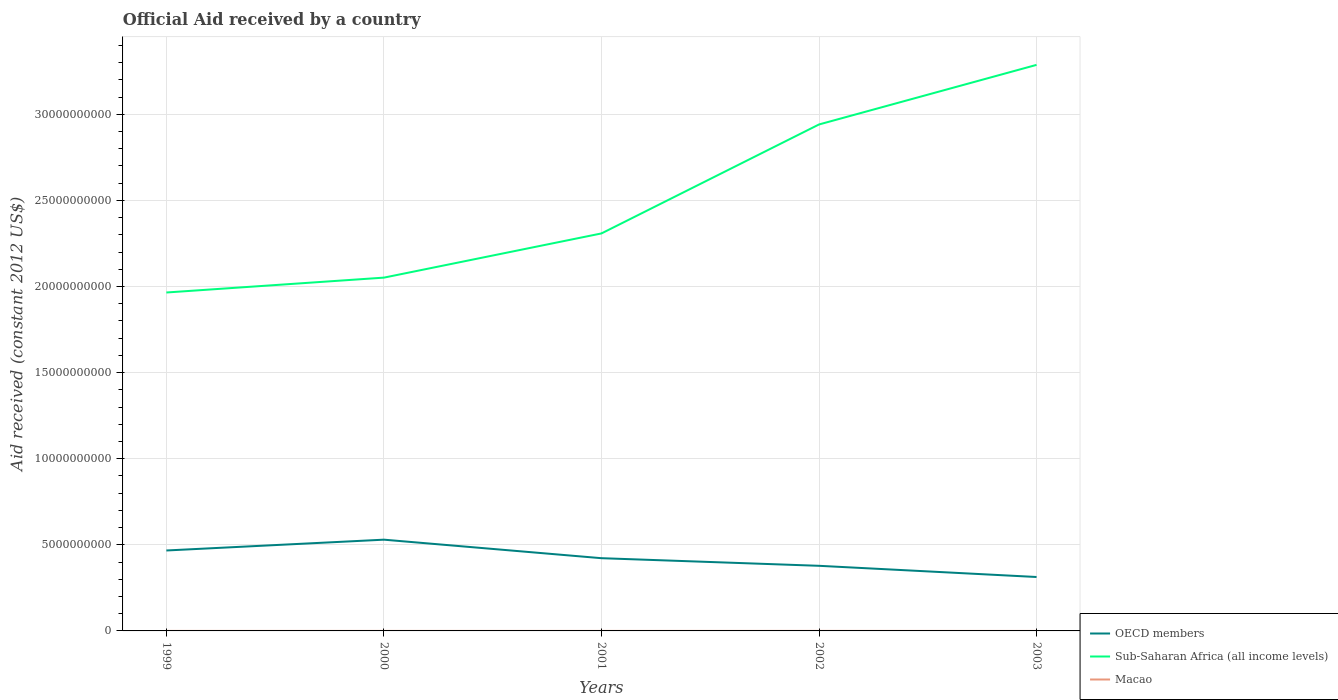How many different coloured lines are there?
Ensure brevity in your answer.  3. Does the line corresponding to Macao intersect with the line corresponding to Sub-Saharan Africa (all income levels)?
Give a very brief answer. No. Is the number of lines equal to the number of legend labels?
Keep it short and to the point. Yes. Across all years, what is the maximum net official aid received in Sub-Saharan Africa (all income levels)?
Your answer should be compact. 1.96e+1. What is the total net official aid received in Macao in the graph?
Make the answer very short. -7.20e+05. What is the difference between the highest and the second highest net official aid received in Macao?
Your answer should be compact. 1.40e+06. Is the net official aid received in OECD members strictly greater than the net official aid received in Sub-Saharan Africa (all income levels) over the years?
Ensure brevity in your answer.  Yes. How many years are there in the graph?
Offer a terse response. 5. What is the difference between two consecutive major ticks on the Y-axis?
Offer a terse response. 5.00e+09. Are the values on the major ticks of Y-axis written in scientific E-notation?
Provide a succinct answer. No. Does the graph contain any zero values?
Keep it short and to the point. No. Where does the legend appear in the graph?
Provide a succinct answer. Bottom right. How many legend labels are there?
Provide a short and direct response. 3. What is the title of the graph?
Your response must be concise. Official Aid received by a country. What is the label or title of the X-axis?
Offer a terse response. Years. What is the label or title of the Y-axis?
Provide a succinct answer. Aid received (constant 2012 US$). What is the Aid received (constant 2012 US$) of OECD members in 1999?
Keep it short and to the point. 4.67e+09. What is the Aid received (constant 2012 US$) of Sub-Saharan Africa (all income levels) in 1999?
Your answer should be very brief. 1.96e+1. What is the Aid received (constant 2012 US$) in Macao in 1999?
Offer a very short reply. 4.20e+05. What is the Aid received (constant 2012 US$) in OECD members in 2000?
Your response must be concise. 5.30e+09. What is the Aid received (constant 2012 US$) of Sub-Saharan Africa (all income levels) in 2000?
Keep it short and to the point. 2.05e+1. What is the Aid received (constant 2012 US$) of Macao in 2000?
Make the answer very short. 1.08e+06. What is the Aid received (constant 2012 US$) of OECD members in 2001?
Offer a very short reply. 4.22e+09. What is the Aid received (constant 2012 US$) of Sub-Saharan Africa (all income levels) in 2001?
Give a very brief answer. 2.31e+1. What is the Aid received (constant 2012 US$) in Macao in 2001?
Your answer should be very brief. 8.60e+05. What is the Aid received (constant 2012 US$) of OECD members in 2002?
Keep it short and to the point. 3.78e+09. What is the Aid received (constant 2012 US$) in Sub-Saharan Africa (all income levels) in 2002?
Your answer should be very brief. 2.94e+1. What is the Aid received (constant 2012 US$) in Macao in 2002?
Your response must be concise. 1.58e+06. What is the Aid received (constant 2012 US$) of OECD members in 2003?
Your answer should be compact. 3.13e+09. What is the Aid received (constant 2012 US$) of Sub-Saharan Africa (all income levels) in 2003?
Your answer should be compact. 3.29e+1. What is the Aid received (constant 2012 US$) in Macao in 2003?
Offer a terse response. 1.80e+05. Across all years, what is the maximum Aid received (constant 2012 US$) of OECD members?
Keep it short and to the point. 5.30e+09. Across all years, what is the maximum Aid received (constant 2012 US$) in Sub-Saharan Africa (all income levels)?
Provide a succinct answer. 3.29e+1. Across all years, what is the maximum Aid received (constant 2012 US$) in Macao?
Keep it short and to the point. 1.58e+06. Across all years, what is the minimum Aid received (constant 2012 US$) of OECD members?
Provide a succinct answer. 3.13e+09. Across all years, what is the minimum Aid received (constant 2012 US$) of Sub-Saharan Africa (all income levels)?
Give a very brief answer. 1.96e+1. What is the total Aid received (constant 2012 US$) of OECD members in the graph?
Provide a succinct answer. 2.11e+1. What is the total Aid received (constant 2012 US$) in Sub-Saharan Africa (all income levels) in the graph?
Ensure brevity in your answer.  1.26e+11. What is the total Aid received (constant 2012 US$) in Macao in the graph?
Provide a succinct answer. 4.12e+06. What is the difference between the Aid received (constant 2012 US$) of OECD members in 1999 and that in 2000?
Ensure brevity in your answer.  -6.28e+08. What is the difference between the Aid received (constant 2012 US$) of Sub-Saharan Africa (all income levels) in 1999 and that in 2000?
Give a very brief answer. -8.63e+08. What is the difference between the Aid received (constant 2012 US$) of Macao in 1999 and that in 2000?
Your answer should be compact. -6.60e+05. What is the difference between the Aid received (constant 2012 US$) of OECD members in 1999 and that in 2001?
Your answer should be compact. 4.47e+08. What is the difference between the Aid received (constant 2012 US$) of Sub-Saharan Africa (all income levels) in 1999 and that in 2001?
Provide a short and direct response. -3.43e+09. What is the difference between the Aid received (constant 2012 US$) in Macao in 1999 and that in 2001?
Offer a very short reply. -4.40e+05. What is the difference between the Aid received (constant 2012 US$) in OECD members in 1999 and that in 2002?
Offer a terse response. 8.89e+08. What is the difference between the Aid received (constant 2012 US$) of Sub-Saharan Africa (all income levels) in 1999 and that in 2002?
Offer a very short reply. -9.76e+09. What is the difference between the Aid received (constant 2012 US$) in Macao in 1999 and that in 2002?
Keep it short and to the point. -1.16e+06. What is the difference between the Aid received (constant 2012 US$) in OECD members in 1999 and that in 2003?
Your response must be concise. 1.54e+09. What is the difference between the Aid received (constant 2012 US$) of Sub-Saharan Africa (all income levels) in 1999 and that in 2003?
Offer a terse response. -1.32e+1. What is the difference between the Aid received (constant 2012 US$) of OECD members in 2000 and that in 2001?
Provide a succinct answer. 1.08e+09. What is the difference between the Aid received (constant 2012 US$) in Sub-Saharan Africa (all income levels) in 2000 and that in 2001?
Offer a terse response. -2.57e+09. What is the difference between the Aid received (constant 2012 US$) in OECD members in 2000 and that in 2002?
Ensure brevity in your answer.  1.52e+09. What is the difference between the Aid received (constant 2012 US$) in Sub-Saharan Africa (all income levels) in 2000 and that in 2002?
Your answer should be compact. -8.89e+09. What is the difference between the Aid received (constant 2012 US$) of Macao in 2000 and that in 2002?
Provide a succinct answer. -5.00e+05. What is the difference between the Aid received (constant 2012 US$) in OECD members in 2000 and that in 2003?
Ensure brevity in your answer.  2.17e+09. What is the difference between the Aid received (constant 2012 US$) in Sub-Saharan Africa (all income levels) in 2000 and that in 2003?
Your answer should be compact. -1.24e+1. What is the difference between the Aid received (constant 2012 US$) in OECD members in 2001 and that in 2002?
Provide a short and direct response. 4.42e+08. What is the difference between the Aid received (constant 2012 US$) of Sub-Saharan Africa (all income levels) in 2001 and that in 2002?
Provide a succinct answer. -6.33e+09. What is the difference between the Aid received (constant 2012 US$) of Macao in 2001 and that in 2002?
Give a very brief answer. -7.20e+05. What is the difference between the Aid received (constant 2012 US$) in OECD members in 2001 and that in 2003?
Keep it short and to the point. 1.09e+09. What is the difference between the Aid received (constant 2012 US$) of Sub-Saharan Africa (all income levels) in 2001 and that in 2003?
Make the answer very short. -9.79e+09. What is the difference between the Aid received (constant 2012 US$) of Macao in 2001 and that in 2003?
Offer a terse response. 6.80e+05. What is the difference between the Aid received (constant 2012 US$) in OECD members in 2002 and that in 2003?
Give a very brief answer. 6.50e+08. What is the difference between the Aid received (constant 2012 US$) in Sub-Saharan Africa (all income levels) in 2002 and that in 2003?
Make the answer very short. -3.46e+09. What is the difference between the Aid received (constant 2012 US$) of Macao in 2002 and that in 2003?
Keep it short and to the point. 1.40e+06. What is the difference between the Aid received (constant 2012 US$) in OECD members in 1999 and the Aid received (constant 2012 US$) in Sub-Saharan Africa (all income levels) in 2000?
Provide a succinct answer. -1.58e+1. What is the difference between the Aid received (constant 2012 US$) of OECD members in 1999 and the Aid received (constant 2012 US$) of Macao in 2000?
Keep it short and to the point. 4.67e+09. What is the difference between the Aid received (constant 2012 US$) of Sub-Saharan Africa (all income levels) in 1999 and the Aid received (constant 2012 US$) of Macao in 2000?
Offer a very short reply. 1.96e+1. What is the difference between the Aid received (constant 2012 US$) in OECD members in 1999 and the Aid received (constant 2012 US$) in Sub-Saharan Africa (all income levels) in 2001?
Ensure brevity in your answer.  -1.84e+1. What is the difference between the Aid received (constant 2012 US$) of OECD members in 1999 and the Aid received (constant 2012 US$) of Macao in 2001?
Your answer should be very brief. 4.67e+09. What is the difference between the Aid received (constant 2012 US$) of Sub-Saharan Africa (all income levels) in 1999 and the Aid received (constant 2012 US$) of Macao in 2001?
Your response must be concise. 1.96e+1. What is the difference between the Aid received (constant 2012 US$) of OECD members in 1999 and the Aid received (constant 2012 US$) of Sub-Saharan Africa (all income levels) in 2002?
Offer a very short reply. -2.47e+1. What is the difference between the Aid received (constant 2012 US$) of OECD members in 1999 and the Aid received (constant 2012 US$) of Macao in 2002?
Provide a short and direct response. 4.67e+09. What is the difference between the Aid received (constant 2012 US$) of Sub-Saharan Africa (all income levels) in 1999 and the Aid received (constant 2012 US$) of Macao in 2002?
Ensure brevity in your answer.  1.96e+1. What is the difference between the Aid received (constant 2012 US$) of OECD members in 1999 and the Aid received (constant 2012 US$) of Sub-Saharan Africa (all income levels) in 2003?
Provide a succinct answer. -2.82e+1. What is the difference between the Aid received (constant 2012 US$) of OECD members in 1999 and the Aid received (constant 2012 US$) of Macao in 2003?
Your answer should be very brief. 4.67e+09. What is the difference between the Aid received (constant 2012 US$) of Sub-Saharan Africa (all income levels) in 1999 and the Aid received (constant 2012 US$) of Macao in 2003?
Keep it short and to the point. 1.96e+1. What is the difference between the Aid received (constant 2012 US$) of OECD members in 2000 and the Aid received (constant 2012 US$) of Sub-Saharan Africa (all income levels) in 2001?
Ensure brevity in your answer.  -1.78e+1. What is the difference between the Aid received (constant 2012 US$) of OECD members in 2000 and the Aid received (constant 2012 US$) of Macao in 2001?
Offer a terse response. 5.30e+09. What is the difference between the Aid received (constant 2012 US$) in Sub-Saharan Africa (all income levels) in 2000 and the Aid received (constant 2012 US$) in Macao in 2001?
Offer a terse response. 2.05e+1. What is the difference between the Aid received (constant 2012 US$) of OECD members in 2000 and the Aid received (constant 2012 US$) of Sub-Saharan Africa (all income levels) in 2002?
Give a very brief answer. -2.41e+1. What is the difference between the Aid received (constant 2012 US$) of OECD members in 2000 and the Aid received (constant 2012 US$) of Macao in 2002?
Provide a succinct answer. 5.30e+09. What is the difference between the Aid received (constant 2012 US$) in Sub-Saharan Africa (all income levels) in 2000 and the Aid received (constant 2012 US$) in Macao in 2002?
Give a very brief answer. 2.05e+1. What is the difference between the Aid received (constant 2012 US$) of OECD members in 2000 and the Aid received (constant 2012 US$) of Sub-Saharan Africa (all income levels) in 2003?
Offer a terse response. -2.76e+1. What is the difference between the Aid received (constant 2012 US$) of OECD members in 2000 and the Aid received (constant 2012 US$) of Macao in 2003?
Your answer should be very brief. 5.30e+09. What is the difference between the Aid received (constant 2012 US$) in Sub-Saharan Africa (all income levels) in 2000 and the Aid received (constant 2012 US$) in Macao in 2003?
Keep it short and to the point. 2.05e+1. What is the difference between the Aid received (constant 2012 US$) in OECD members in 2001 and the Aid received (constant 2012 US$) in Sub-Saharan Africa (all income levels) in 2002?
Your answer should be very brief. -2.52e+1. What is the difference between the Aid received (constant 2012 US$) of OECD members in 2001 and the Aid received (constant 2012 US$) of Macao in 2002?
Keep it short and to the point. 4.22e+09. What is the difference between the Aid received (constant 2012 US$) of Sub-Saharan Africa (all income levels) in 2001 and the Aid received (constant 2012 US$) of Macao in 2002?
Your answer should be very brief. 2.31e+1. What is the difference between the Aid received (constant 2012 US$) of OECD members in 2001 and the Aid received (constant 2012 US$) of Sub-Saharan Africa (all income levels) in 2003?
Your answer should be compact. -2.86e+1. What is the difference between the Aid received (constant 2012 US$) of OECD members in 2001 and the Aid received (constant 2012 US$) of Macao in 2003?
Provide a short and direct response. 4.22e+09. What is the difference between the Aid received (constant 2012 US$) in Sub-Saharan Africa (all income levels) in 2001 and the Aid received (constant 2012 US$) in Macao in 2003?
Offer a very short reply. 2.31e+1. What is the difference between the Aid received (constant 2012 US$) of OECD members in 2002 and the Aid received (constant 2012 US$) of Sub-Saharan Africa (all income levels) in 2003?
Give a very brief answer. -2.91e+1. What is the difference between the Aid received (constant 2012 US$) of OECD members in 2002 and the Aid received (constant 2012 US$) of Macao in 2003?
Offer a terse response. 3.78e+09. What is the difference between the Aid received (constant 2012 US$) in Sub-Saharan Africa (all income levels) in 2002 and the Aid received (constant 2012 US$) in Macao in 2003?
Make the answer very short. 2.94e+1. What is the average Aid received (constant 2012 US$) of OECD members per year?
Keep it short and to the point. 4.22e+09. What is the average Aid received (constant 2012 US$) in Sub-Saharan Africa (all income levels) per year?
Your response must be concise. 2.51e+1. What is the average Aid received (constant 2012 US$) of Macao per year?
Give a very brief answer. 8.24e+05. In the year 1999, what is the difference between the Aid received (constant 2012 US$) of OECD members and Aid received (constant 2012 US$) of Sub-Saharan Africa (all income levels)?
Give a very brief answer. -1.50e+1. In the year 1999, what is the difference between the Aid received (constant 2012 US$) in OECD members and Aid received (constant 2012 US$) in Macao?
Keep it short and to the point. 4.67e+09. In the year 1999, what is the difference between the Aid received (constant 2012 US$) in Sub-Saharan Africa (all income levels) and Aid received (constant 2012 US$) in Macao?
Provide a succinct answer. 1.96e+1. In the year 2000, what is the difference between the Aid received (constant 2012 US$) of OECD members and Aid received (constant 2012 US$) of Sub-Saharan Africa (all income levels)?
Make the answer very short. -1.52e+1. In the year 2000, what is the difference between the Aid received (constant 2012 US$) in OECD members and Aid received (constant 2012 US$) in Macao?
Provide a short and direct response. 5.30e+09. In the year 2000, what is the difference between the Aid received (constant 2012 US$) of Sub-Saharan Africa (all income levels) and Aid received (constant 2012 US$) of Macao?
Offer a terse response. 2.05e+1. In the year 2001, what is the difference between the Aid received (constant 2012 US$) of OECD members and Aid received (constant 2012 US$) of Sub-Saharan Africa (all income levels)?
Provide a short and direct response. -1.89e+1. In the year 2001, what is the difference between the Aid received (constant 2012 US$) of OECD members and Aid received (constant 2012 US$) of Macao?
Keep it short and to the point. 4.22e+09. In the year 2001, what is the difference between the Aid received (constant 2012 US$) in Sub-Saharan Africa (all income levels) and Aid received (constant 2012 US$) in Macao?
Provide a succinct answer. 2.31e+1. In the year 2002, what is the difference between the Aid received (constant 2012 US$) in OECD members and Aid received (constant 2012 US$) in Sub-Saharan Africa (all income levels)?
Offer a terse response. -2.56e+1. In the year 2002, what is the difference between the Aid received (constant 2012 US$) of OECD members and Aid received (constant 2012 US$) of Macao?
Provide a succinct answer. 3.78e+09. In the year 2002, what is the difference between the Aid received (constant 2012 US$) in Sub-Saharan Africa (all income levels) and Aid received (constant 2012 US$) in Macao?
Ensure brevity in your answer.  2.94e+1. In the year 2003, what is the difference between the Aid received (constant 2012 US$) in OECD members and Aid received (constant 2012 US$) in Sub-Saharan Africa (all income levels)?
Keep it short and to the point. -2.97e+1. In the year 2003, what is the difference between the Aid received (constant 2012 US$) in OECD members and Aid received (constant 2012 US$) in Macao?
Ensure brevity in your answer.  3.13e+09. In the year 2003, what is the difference between the Aid received (constant 2012 US$) of Sub-Saharan Africa (all income levels) and Aid received (constant 2012 US$) of Macao?
Make the answer very short. 3.29e+1. What is the ratio of the Aid received (constant 2012 US$) in OECD members in 1999 to that in 2000?
Offer a very short reply. 0.88. What is the ratio of the Aid received (constant 2012 US$) in Sub-Saharan Africa (all income levels) in 1999 to that in 2000?
Your answer should be compact. 0.96. What is the ratio of the Aid received (constant 2012 US$) of Macao in 1999 to that in 2000?
Keep it short and to the point. 0.39. What is the ratio of the Aid received (constant 2012 US$) of OECD members in 1999 to that in 2001?
Give a very brief answer. 1.11. What is the ratio of the Aid received (constant 2012 US$) of Sub-Saharan Africa (all income levels) in 1999 to that in 2001?
Provide a succinct answer. 0.85. What is the ratio of the Aid received (constant 2012 US$) of Macao in 1999 to that in 2001?
Ensure brevity in your answer.  0.49. What is the ratio of the Aid received (constant 2012 US$) in OECD members in 1999 to that in 2002?
Give a very brief answer. 1.24. What is the ratio of the Aid received (constant 2012 US$) of Sub-Saharan Africa (all income levels) in 1999 to that in 2002?
Provide a short and direct response. 0.67. What is the ratio of the Aid received (constant 2012 US$) in Macao in 1999 to that in 2002?
Your answer should be very brief. 0.27. What is the ratio of the Aid received (constant 2012 US$) in OECD members in 1999 to that in 2003?
Make the answer very short. 1.49. What is the ratio of the Aid received (constant 2012 US$) in Sub-Saharan Africa (all income levels) in 1999 to that in 2003?
Your response must be concise. 0.6. What is the ratio of the Aid received (constant 2012 US$) in Macao in 1999 to that in 2003?
Offer a terse response. 2.33. What is the ratio of the Aid received (constant 2012 US$) in OECD members in 2000 to that in 2001?
Keep it short and to the point. 1.25. What is the ratio of the Aid received (constant 2012 US$) in Sub-Saharan Africa (all income levels) in 2000 to that in 2001?
Your response must be concise. 0.89. What is the ratio of the Aid received (constant 2012 US$) of Macao in 2000 to that in 2001?
Offer a very short reply. 1.26. What is the ratio of the Aid received (constant 2012 US$) of OECD members in 2000 to that in 2002?
Your answer should be compact. 1.4. What is the ratio of the Aid received (constant 2012 US$) in Sub-Saharan Africa (all income levels) in 2000 to that in 2002?
Offer a very short reply. 0.7. What is the ratio of the Aid received (constant 2012 US$) of Macao in 2000 to that in 2002?
Make the answer very short. 0.68. What is the ratio of the Aid received (constant 2012 US$) of OECD members in 2000 to that in 2003?
Keep it short and to the point. 1.69. What is the ratio of the Aid received (constant 2012 US$) in Sub-Saharan Africa (all income levels) in 2000 to that in 2003?
Give a very brief answer. 0.62. What is the ratio of the Aid received (constant 2012 US$) of OECD members in 2001 to that in 2002?
Offer a terse response. 1.12. What is the ratio of the Aid received (constant 2012 US$) of Sub-Saharan Africa (all income levels) in 2001 to that in 2002?
Your answer should be compact. 0.78. What is the ratio of the Aid received (constant 2012 US$) of Macao in 2001 to that in 2002?
Provide a short and direct response. 0.54. What is the ratio of the Aid received (constant 2012 US$) of OECD members in 2001 to that in 2003?
Give a very brief answer. 1.35. What is the ratio of the Aid received (constant 2012 US$) of Sub-Saharan Africa (all income levels) in 2001 to that in 2003?
Offer a terse response. 0.7. What is the ratio of the Aid received (constant 2012 US$) of Macao in 2001 to that in 2003?
Give a very brief answer. 4.78. What is the ratio of the Aid received (constant 2012 US$) of OECD members in 2002 to that in 2003?
Keep it short and to the point. 1.21. What is the ratio of the Aid received (constant 2012 US$) of Sub-Saharan Africa (all income levels) in 2002 to that in 2003?
Your answer should be compact. 0.89. What is the ratio of the Aid received (constant 2012 US$) in Macao in 2002 to that in 2003?
Make the answer very short. 8.78. What is the difference between the highest and the second highest Aid received (constant 2012 US$) in OECD members?
Your response must be concise. 6.28e+08. What is the difference between the highest and the second highest Aid received (constant 2012 US$) of Sub-Saharan Africa (all income levels)?
Make the answer very short. 3.46e+09. What is the difference between the highest and the lowest Aid received (constant 2012 US$) of OECD members?
Offer a terse response. 2.17e+09. What is the difference between the highest and the lowest Aid received (constant 2012 US$) of Sub-Saharan Africa (all income levels)?
Your answer should be very brief. 1.32e+1. What is the difference between the highest and the lowest Aid received (constant 2012 US$) of Macao?
Your answer should be compact. 1.40e+06. 